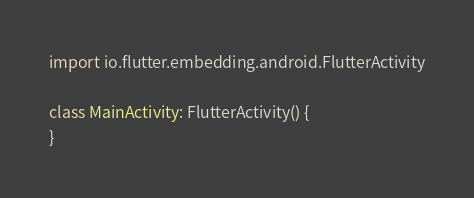<code> <loc_0><loc_0><loc_500><loc_500><_Kotlin_>
import io.flutter.embedding.android.FlutterActivity

class MainActivity: FlutterActivity() {
}
</code> 